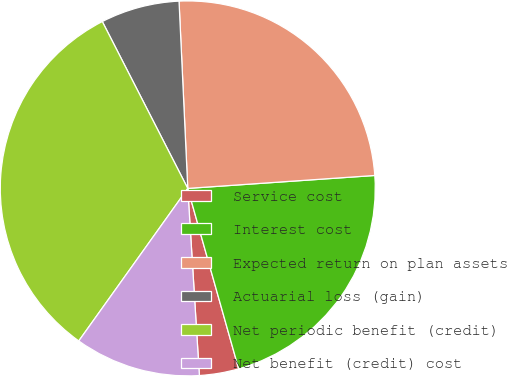<chart> <loc_0><loc_0><loc_500><loc_500><pie_chart><fcel>Service cost<fcel>Interest cost<fcel>Expected return on plan assets<fcel>Actuarial loss (gain)<fcel>Net periodic benefit (credit)<fcel>Net benefit (credit) cost<nl><fcel>3.39%<fcel>21.72%<fcel>24.64%<fcel>6.79%<fcel>32.59%<fcel>10.86%<nl></chart> 